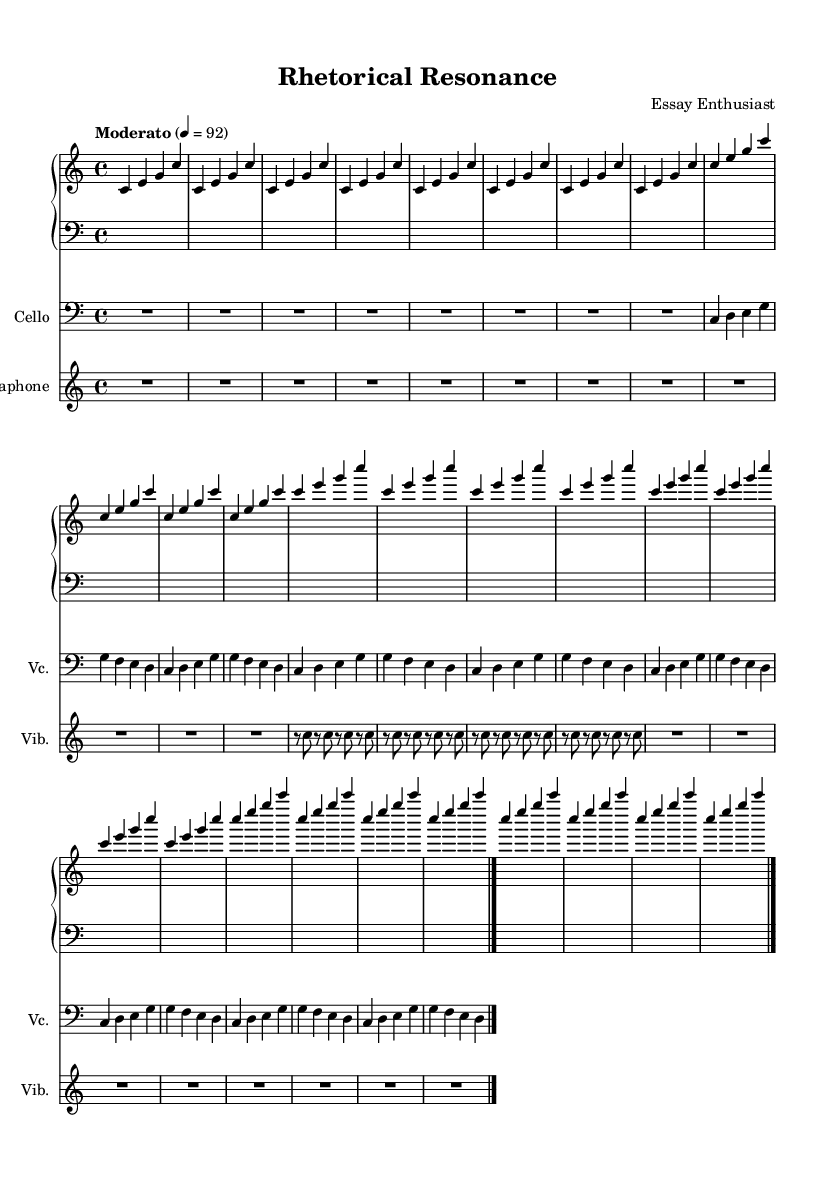What is the key signature of this music? The key signature is C major, which has no sharps or flats, as indicated by the lack of any accidental symbols in the staff.
Answer: C major What is the time signature of this music? The time signature is 4/4, which means there are four beats in each measure and the quarter note gets one beat. This is noted at the beginning of the staff.
Answer: 4/4 What is the tempo marking of this composition? The tempo marking is "Moderato," which suggests a moderate speed, indicated at the start of the piece along with the metronome marking.
Answer: Moderato How many repetitions are there in the Introduction section for the piano part? There are eight repetitions of the motif in the Introduction section as indicated by the notation that specifies to repeat the figure eight times.
Answer: 8 What is the function of the cello part in this composition? The cello part serves to elaborate on the main theme, providing melodic support (thesis), development (body), and closure (conclusion) similar to a persuasive essay structure. This is identifiable through the distinct sections labeled by their thematic development.
Answer: Elaborate melodic support What unique structural component does this composition borrow from persuasive essays? The composition mirrors the structure of a persuasive essay, with clearly defined sections corresponding to Introduction, Thesis, Body, and Conclusion, illustrating the speech-like progression of ideas in musical form.
Answer: Essay structure What instrument plays the rhythmic accompaniment in the Body Paragraph 1 section? The vibraphone plays the rhythmic accompaniment in the Body Paragraph 1 section, as indicated by the notation that contains rests and notes solely in that part during this section.
Answer: Vibraphone 